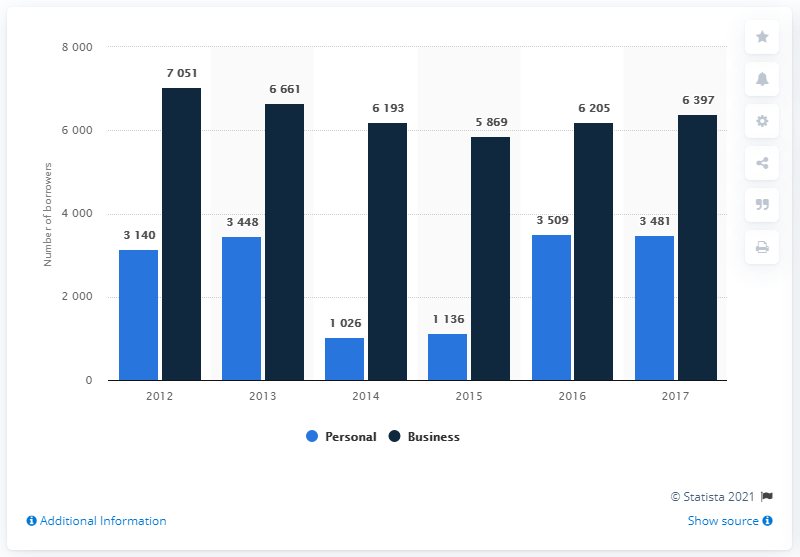Highlight a few significant elements in this photo. In 2017, 6,397 borrowers in North Macedonia took out credit for business purposes. 